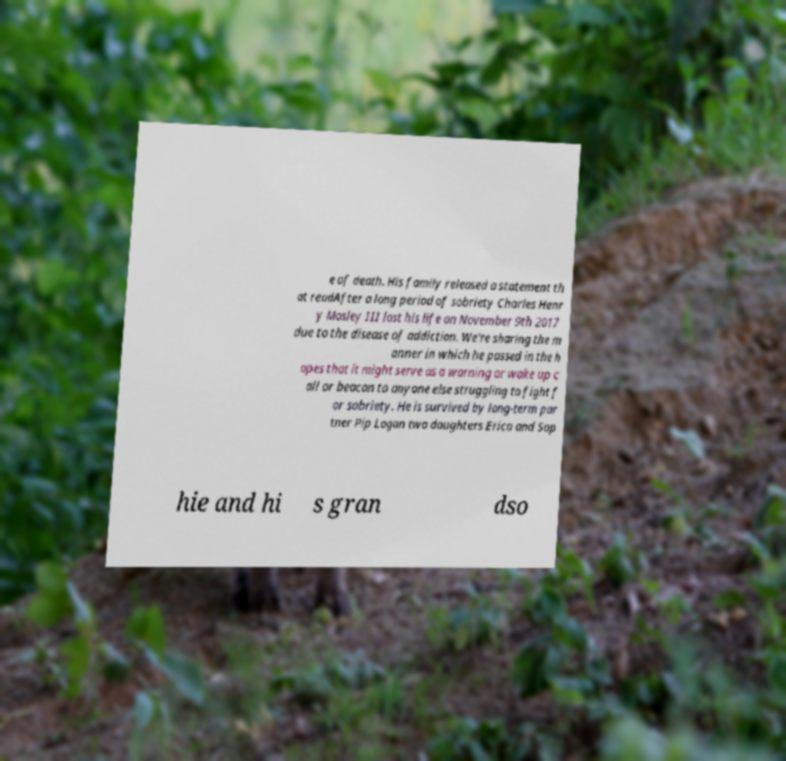I need the written content from this picture converted into text. Can you do that? e of death. His family released a statement th at readAfter a long period of sobriety Charles Henr y Mosley III lost his life on November 9th 2017 due to the disease of addiction. We're sharing the m anner in which he passed in the h opes that it might serve as a warning or wake up c all or beacon to anyone else struggling to fight f or sobriety. He is survived by long-term par tner Pip Logan two daughters Erica and Sop hie and hi s gran dso 